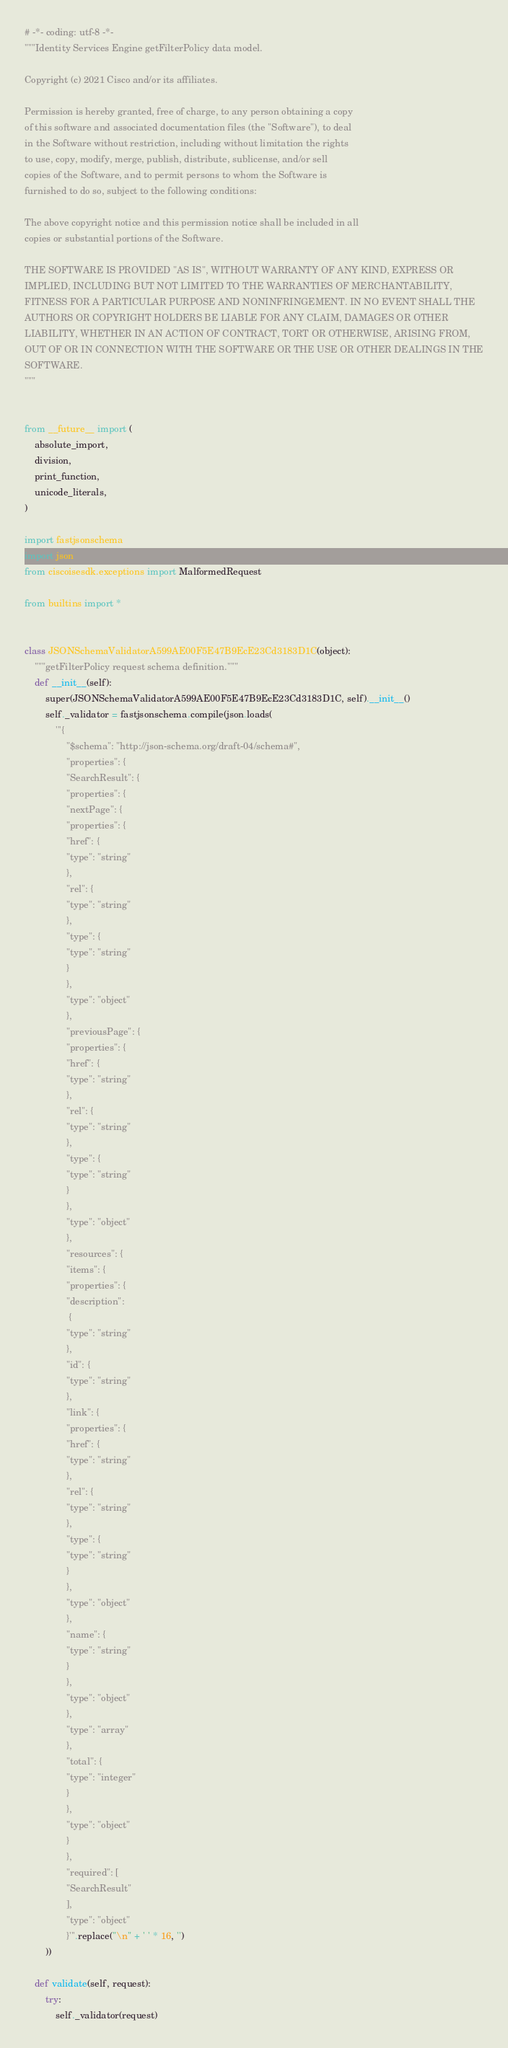<code> <loc_0><loc_0><loc_500><loc_500><_Python_># -*- coding: utf-8 -*-
"""Identity Services Engine getFilterPolicy data model.

Copyright (c) 2021 Cisco and/or its affiliates.

Permission is hereby granted, free of charge, to any person obtaining a copy
of this software and associated documentation files (the "Software"), to deal
in the Software without restriction, including without limitation the rights
to use, copy, modify, merge, publish, distribute, sublicense, and/or sell
copies of the Software, and to permit persons to whom the Software is
furnished to do so, subject to the following conditions:

The above copyright notice and this permission notice shall be included in all
copies or substantial portions of the Software.

THE SOFTWARE IS PROVIDED "AS IS", WITHOUT WARRANTY OF ANY KIND, EXPRESS OR
IMPLIED, INCLUDING BUT NOT LIMITED TO THE WARRANTIES OF MERCHANTABILITY,
FITNESS FOR A PARTICULAR PURPOSE AND NONINFRINGEMENT. IN NO EVENT SHALL THE
AUTHORS OR COPYRIGHT HOLDERS BE LIABLE FOR ANY CLAIM, DAMAGES OR OTHER
LIABILITY, WHETHER IN AN ACTION OF CONTRACT, TORT OR OTHERWISE, ARISING FROM,
OUT OF OR IN CONNECTION WITH THE SOFTWARE OR THE USE OR OTHER DEALINGS IN THE
SOFTWARE.
"""


from __future__ import (
    absolute_import,
    division,
    print_function,
    unicode_literals,
)

import fastjsonschema
import json
from ciscoisesdk.exceptions import MalformedRequest

from builtins import *


class JSONSchemaValidatorA599AE00F5E47B9EcE23Cd3183D1C(object):
    """getFilterPolicy request schema definition."""
    def __init__(self):
        super(JSONSchemaValidatorA599AE00F5E47B9EcE23Cd3183D1C, self).__init__()
        self._validator = fastjsonschema.compile(json.loads(
            '''{
                "$schema": "http://json-schema.org/draft-04/schema#",
                "properties": {
                "SearchResult": {
                "properties": {
                "nextPage": {
                "properties": {
                "href": {
                "type": "string"
                },
                "rel": {
                "type": "string"
                },
                "type": {
                "type": "string"
                }
                },
                "type": "object"
                },
                "previousPage": {
                "properties": {
                "href": {
                "type": "string"
                },
                "rel": {
                "type": "string"
                },
                "type": {
                "type": "string"
                }
                },
                "type": "object"
                },
                "resources": {
                "items": {
                "properties": {
                "description":
                 {
                "type": "string"
                },
                "id": {
                "type": "string"
                },
                "link": {
                "properties": {
                "href": {
                "type": "string"
                },
                "rel": {
                "type": "string"
                },
                "type": {
                "type": "string"
                }
                },
                "type": "object"
                },
                "name": {
                "type": "string"
                }
                },
                "type": "object"
                },
                "type": "array"
                },
                "total": {
                "type": "integer"
                }
                },
                "type": "object"
                }
                },
                "required": [
                "SearchResult"
                ],
                "type": "object"
                }'''.replace("\n" + ' ' * 16, '')
        ))

    def validate(self, request):
        try:
            self._validator(request)</code> 